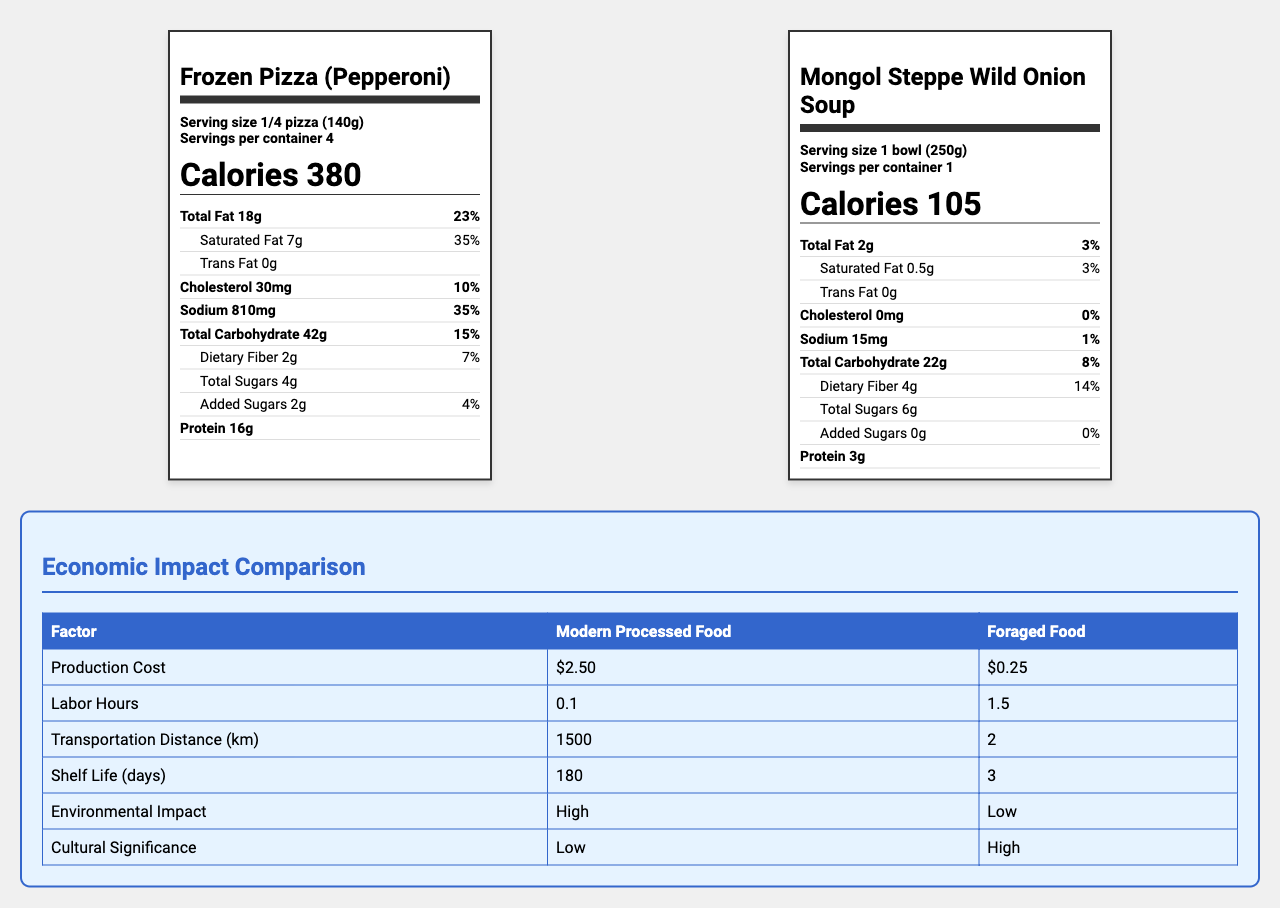what is the serving size for the modern processed food? The serving size is indicated as "1/4 pizza (140g)" on the nutrition label for the Frozen Pizza (Pepperoni).
Answer: 1/4 pizza (140g) how many calories are in one serving of Mongol Steppe Wild Onion Soup? The nutrition label for Mongol Steppe Wild Onion Soup indicates that one serving has 105 calories.
Answer: 105 what is the total fat content in the Mongol Steppe Wild Onion Soup? The label shows that the total fat content in the Mongol Steppe Wild Onion Soup is 2g.
Answer: 2g what is the daily value percentage of sodium in Frozen Pizza (Pepperoni)? The daily value percentage for sodium in Frozen Pizza (Pepperoni) is shown as 35%.
Answer: 35% how much dietary fiber is in a serving of Mongol Steppe Wild Onion Soup? The dietary fiber content in Mongol Steppe Wild Onion Soup is listed as 4g on the label.
Answer: 4g which food item has a higher production cost? A. Frozen Pizza (Pepperoni) B. Mongol Steppe Wild Onion Soup The economic impact section shows that the production cost for modern processed food is $2.50, whereas foraged food is $0.25.
Answer: A how long is the shelf life for Frozen Pizza (Pepperoni)? A. 3 days B. 30 days C. 180 days The economic impact section in the document shows that the shelf life for modern processed food (Frozen Pizza) is 180 days.
Answer: C which food requires more labor hours? A. Frozen Pizza (Pepperoni) B. Mongol Steppe Wild Onion Soup The document indicates that foraged food requires 1.5 labor hours, whereas modern processed food requires 0.1 labor hours.
Answer: B does the Frozen Pizza (Pepperoni) contain any trans fat? The nutrition label for Frozen Pizza (Pepperoni) indicates 0g of trans fat.
Answer: No summarize the main differences between modern processed food and foraged food presented in the document. This summary captures the nutritional and economic differences between modern processed foods and foraged foods as shown in the document.
Answer: Modern processed food like Frozen Pizza (Pepperoni) is high in calories, fats, and sodium with a long shelf life and high environmental impact. However, it has low production costs and labor hours. Foraged food like Mongol Steppe Wild Onion Soup is lower in calories, fats, and sodium but high in dietary fiber and nutrients like Vitamin C. It has low environmental impact and high cultural significance but requires more labor hours and has a short shelf life. what is the protein content in Frozen Pizza (Pepperoni)? The nutrition label shows that the protein content in Frozen Pizza (Pepperoni) is 16g per serving.
Answer: 16g how much potassium is found in Mongol Steppe Wild Onion Soup? The nutrition label for Mongol Steppe Wild Onion Soup indicates it has 400mg of potassium per serving.
Answer: 400mg how far does modern processed food generally need to be transported? The document states that modern processed food typically has a transportation distance of 1500 km.
Answer: 1500 km are there any added sugars in Mongol Steppe Wild Onion Soup? The nutrition label indicates 0g of added sugars for Mongol Steppe Wild Onion Soup.
Answer: No what is the daily value percentage of total carbohydrates in Mongol Steppe Wild Onion Soup? The nutrition label shows the daily value percentage for total carbohydrates in Mongol Steppe Wild Onion Soup as 8%.
Answer: 8% does the document indicate the amount of vitamins A in the foods? The provided nutrition labels do not mention any information about Vitamin A content.
Answer: Cannot be determined what is the cultural significance of foraged foods compared to modern processed foods? The document indicates that foraged foods have a high cultural significance, whereas modern processed foods have a low cultural significance.
Answer: Higher 